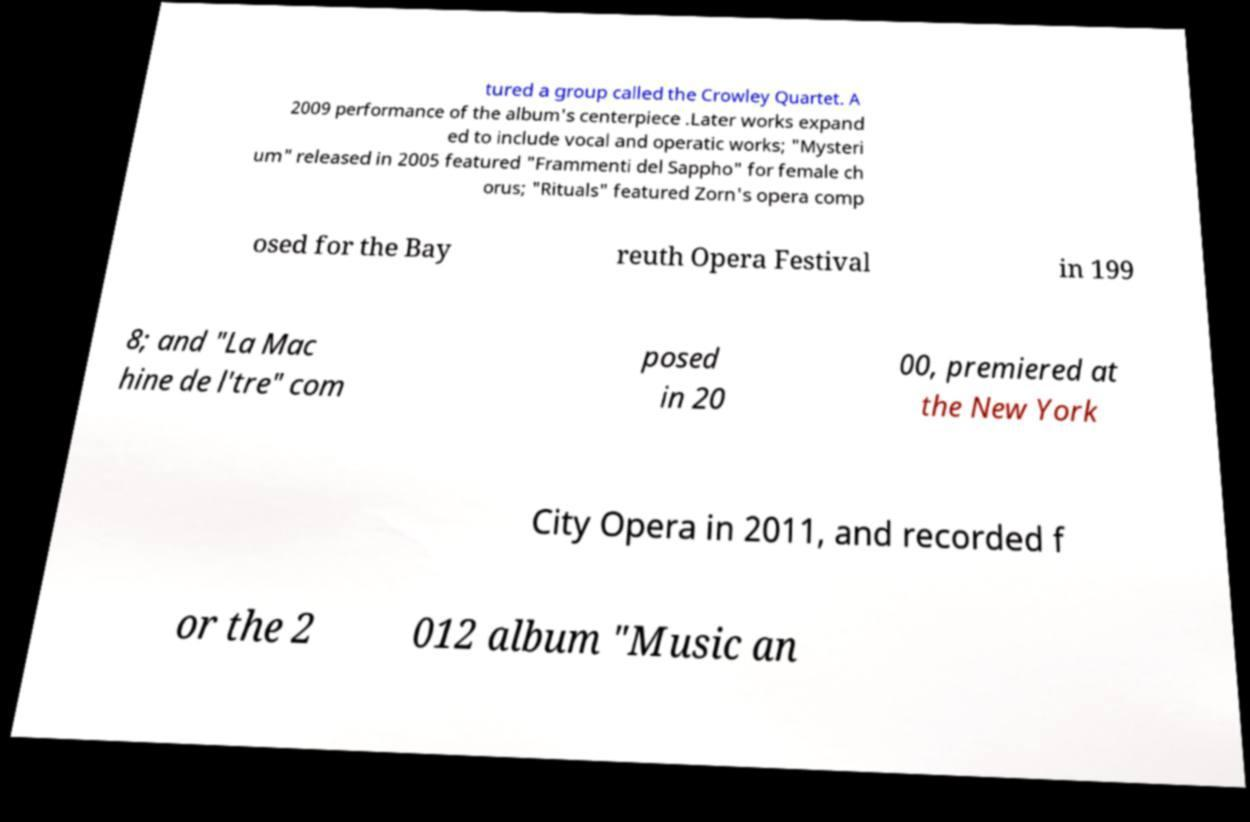Please read and relay the text visible in this image. What does it say? tured a group called the Crowley Quartet. A 2009 performance of the album's centerpiece .Later works expand ed to include vocal and operatic works; "Mysteri um" released in 2005 featured "Frammenti del Sappho" for female ch orus; "Rituals" featured Zorn's opera comp osed for the Bay reuth Opera Festival in 199 8; and "La Mac hine de l'tre" com posed in 20 00, premiered at the New York City Opera in 2011, and recorded f or the 2 012 album "Music an 